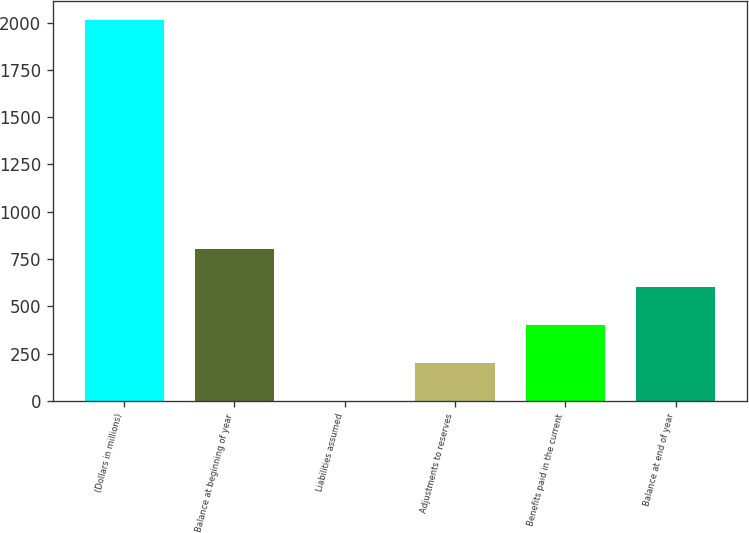Convert chart to OTSL. <chart><loc_0><loc_0><loc_500><loc_500><bar_chart><fcel>(Dollars in millions)<fcel>Balance at beginning of year<fcel>Liabilities assumed<fcel>Adjustments to reserves<fcel>Benefits paid in the current<fcel>Balance at end of year<nl><fcel>2012<fcel>804.86<fcel>0.1<fcel>201.29<fcel>402.48<fcel>603.67<nl></chart> 